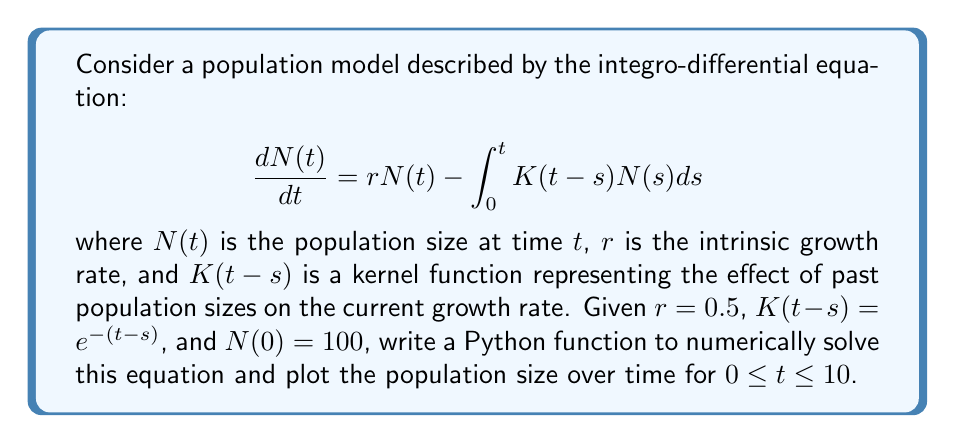Can you answer this question? To solve this integro-differential equation numerically and plot the results using Python, we can follow these steps:

1. Import necessary libraries:
   ```python
   import numpy as np
   from scipy.integrate import odeint, quad
   import matplotlib.pyplot as plt
   ```

2. Define the kernel function:
   ```python
   def K(t):
       return np.exp(-t)
   ```

3. Define the integrand function for the convolution integral:
   ```python
   def integrand(s, t, N_func):
       return K(t - s) * N_func(s)
   ```

4. Define the derivative function for the ODE solver:
   ```python
   def dNdt(N, t, r, N_func):
       integral, _ = quad(integrand, 0, t, args=(t, N_func))
       return r * N - integral
   ```

5. Create a function to interpolate the population values:
   ```python
   def N_interp(t, t_values, N_values):
       return np.interp(t, t_values, N_values)
   ```

6. Set up the parameters and time array:
   ```python
   r = 0.5
   N0 = 100
   t = np.linspace(0, 10, 1000)
   ```

7. Solve the ODE numerically:
   ```python
   def solve_population_model():
       N_values = [N0]
       for i in range(1, len(t)):
           N_func = lambda s: N_interp(s, t[:i], N_values)
           N_new = odeint(dNdt, N_values[-1], [t[i-1], t[i]], args=(r, N_func))
           N_values.append(N_new[1][0])
       return np.array(N_values)

   N = solve_population_model()
   ```

8. Plot the results:
   ```python
   plt.figure(figsize=(10, 6))
   plt.plot(t, N)
   plt.xlabel('Time')
   plt.ylabel('Population size')
   plt.title('Population Dynamics')
   plt.grid(True)
   plt.show()
   ```

This numerical solution approximates the population size over time, taking into account the delayed effects of past population sizes on the current growth rate.
Answer: A Python function using scipy.integrate.odeint and quad to solve the integro-differential equation numerically and matplotlib to plot the results. 